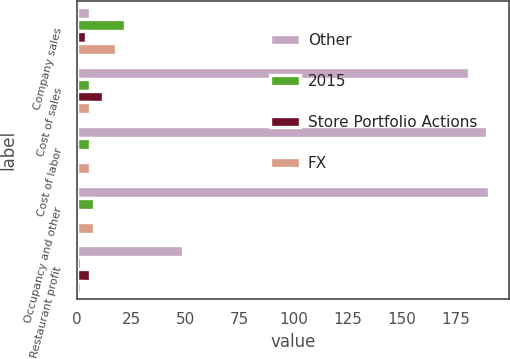Convert chart to OTSL. <chart><loc_0><loc_0><loc_500><loc_500><stacked_bar_chart><ecel><fcel>Company sales<fcel>Cost of sales<fcel>Cost of labor<fcel>Occupancy and other<fcel>Restaurant profit<nl><fcel>Other<fcel>6<fcel>181<fcel>189<fcel>190<fcel>49<nl><fcel>2015<fcel>22<fcel>6<fcel>6<fcel>8<fcel>2<nl><fcel>Store Portfolio Actions<fcel>4<fcel>12<fcel>1<fcel>1<fcel>6<nl><fcel>FX<fcel>18<fcel>6<fcel>6<fcel>8<fcel>2<nl></chart> 